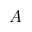<formula> <loc_0><loc_0><loc_500><loc_500>A</formula> 